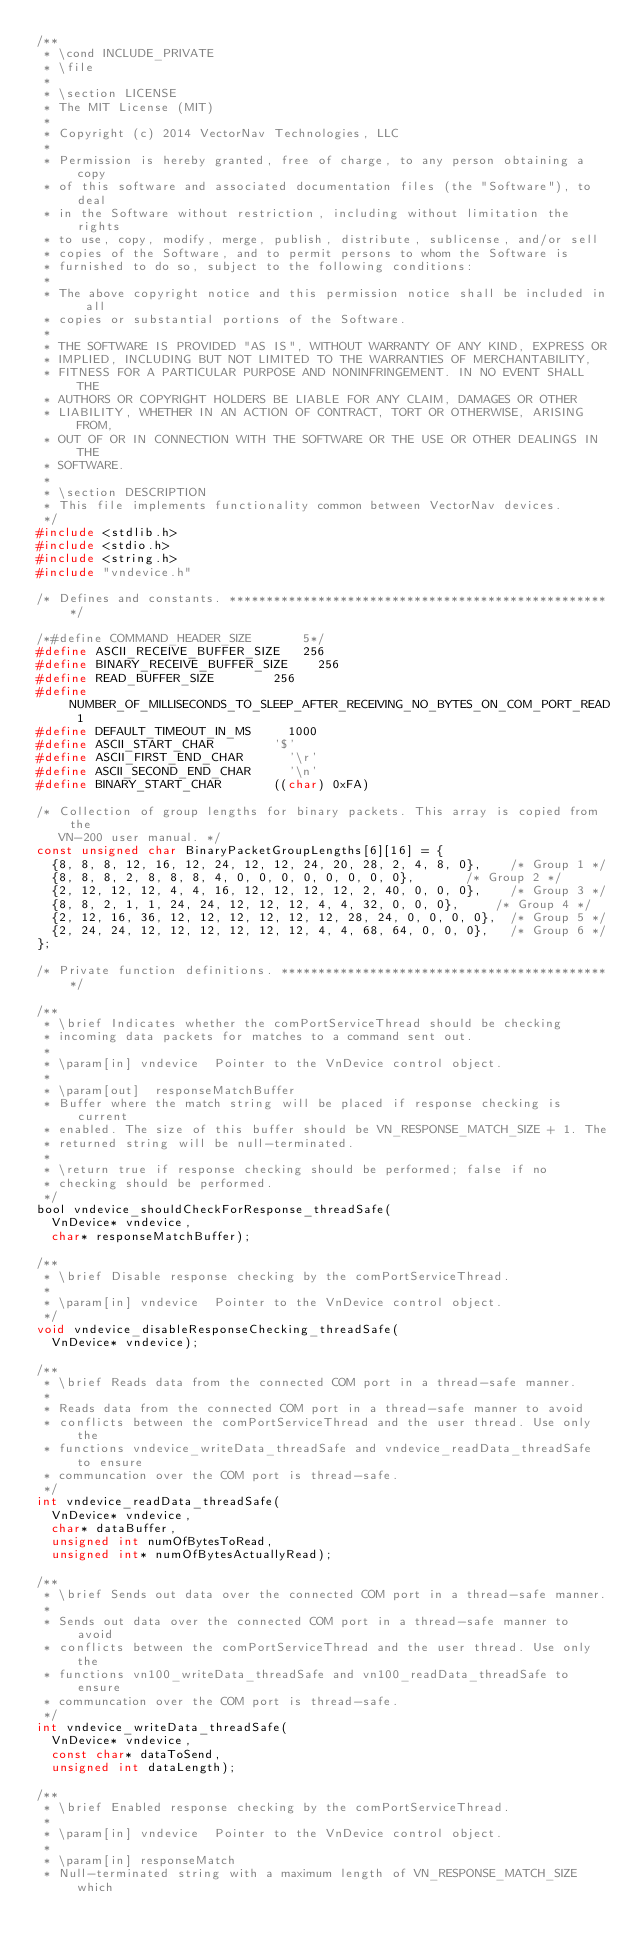<code> <loc_0><loc_0><loc_500><loc_500><_C_>/**
 * \cond INCLUDE_PRIVATE
 * \file
 *
 * \section LICENSE
 * The MIT License (MIT)
 *
 * Copyright (c) 2014 VectorNav Technologies, LLC
 *
 * Permission is hereby granted, free of charge, to any person obtaining a copy
 * of this software and associated documentation files (the "Software"), to deal
 * in the Software without restriction, including without limitation the rights
 * to use, copy, modify, merge, publish, distribute, sublicense, and/or sell
 * copies of the Software, and to permit persons to whom the Software is
 * furnished to do so, subject to the following conditions:
 *
 * The above copyright notice and this permission notice shall be included in all
 * copies or substantial portions of the Software.
 *
 * THE SOFTWARE IS PROVIDED "AS IS", WITHOUT WARRANTY OF ANY KIND, EXPRESS OR
 * IMPLIED, INCLUDING BUT NOT LIMITED TO THE WARRANTIES OF MERCHANTABILITY,
 * FITNESS FOR A PARTICULAR PURPOSE AND NONINFRINGEMENT. IN NO EVENT SHALL THE
 * AUTHORS OR COPYRIGHT HOLDERS BE LIABLE FOR ANY CLAIM, DAMAGES OR OTHER
 * LIABILITY, WHETHER IN AN ACTION OF CONTRACT, TORT OR OTHERWISE, ARISING FROM,
 * OUT OF OR IN CONNECTION WITH THE SOFTWARE OR THE USE OR OTHER DEALINGS IN THE
 * SOFTWARE.
 *
 * \section DESCRIPTION
 * This file implements functionality common between VectorNav devices.
 */
#include <stdlib.h>
#include <stdio.h>
#include <string.h>
#include "vndevice.h"

/* Defines and constants. ****************************************************/

/*#define COMMAND_HEADER_SIZE				5*/
#define ASCII_RECEIVE_BUFFER_SIZE		256
#define BINARY_RECEIVE_BUFFER_SIZE		256
#define READ_BUFFER_SIZE				256
#define NUMBER_OF_MILLISECONDS_TO_SLEEP_AFTER_RECEIVING_NO_BYTES_ON_COM_PORT_READ	1
#define DEFAULT_TIMEOUT_IN_MS			1000
#define ASCII_START_CHAR				'$'
#define ASCII_FIRST_END_CHAR			'\r'
#define ASCII_SECOND_END_CHAR			'\n'
#define BINARY_START_CHAR				((char) 0xFA)

/* Collection of group lengths for binary packets. This array is copied from the
   VN-200 user manual. */
const unsigned char BinaryPacketGroupLengths[6][16] = {
	{8, 8, 8, 12, 16, 12, 24, 12, 12, 24, 20, 28, 2, 4, 8, 0},		/* Group 1 */
	{8, 8, 8, 2, 8, 8, 8, 4, 0, 0, 0, 0, 0, 0, 0, 0},				/* Group 2 */
	{2, 12, 12, 12, 4, 4, 16, 12, 12, 12, 12, 2, 40, 0, 0, 0},		/* Group 3 */
	{8, 8, 2, 1, 1, 24, 24, 12, 12, 12, 4, 4, 32, 0, 0, 0},			/* Group 4 */
	{2, 12, 16, 36, 12, 12, 12, 12, 12, 12, 28, 24, 0, 0, 0, 0},	/* Group 5 */
	{2, 24, 24, 12, 12, 12, 12, 12, 12, 4, 4, 68, 64, 0, 0, 0},		/* Group 6 */
};

/* Private function definitions. *********************************************/

/**
 * \brief Indicates whether the comPortServiceThread should be checking
 * incoming data packets for matches to a command sent out.
 *
 * \param[in]	vndevice	Pointer to the VnDevice control object.
 *
 * \param[out]	responseMatchBuffer
 * Buffer where the match string will be placed if response checking is current
 * enabled. The size of this buffer should be VN_RESPONSE_MATCH_SIZE + 1. The
 * returned string will be null-terminated.
 *
 * \return true if response checking should be performed; false if no
 * checking should be performed.
 */
bool vndevice_shouldCheckForResponse_threadSafe(
	VnDevice* vndevice,
	char* responseMatchBuffer);

/**
 * \brief Disable response checking by the comPortServiceThread.
 *
 * \param[in]	vndevice	Pointer to the VnDevice control object.
 */
void vndevice_disableResponseChecking_threadSafe(
	VnDevice* vndevice);

/**
 * \brief Reads data from the connected COM port in a thread-safe manner.
 *
 * Reads data from the connected COM port in a thread-safe manner to avoid
 * conflicts between the comPortServiceThread and the user thread. Use only the
 * functions vndevice_writeData_threadSafe and vndevice_readData_threadSafe to ensure
 * communcation over the COM port is thread-safe.
 */
int vndevice_readData_threadSafe(
	VnDevice* vndevice,
	char* dataBuffer,
	unsigned int numOfBytesToRead,
	unsigned int* numOfBytesActuallyRead);

/**
 * \brief Sends out data over the connected COM port in a thread-safe manner.
 *
 * Sends out data over the connected COM port in a thread-safe manner to avoid
 * conflicts between the comPortServiceThread and the user thread. Use only the
 * functions vn100_writeData_threadSafe and vn100_readData_threadSafe to ensure
 * communcation over the COM port is thread-safe.
 */
int vndevice_writeData_threadSafe(
	VnDevice* vndevice,
	const char* dataToSend,
	unsigned int dataLength);

/**
 * \brief Enabled response checking by the comPortServiceThread.
 *
 * \param[in]	vndevice	Pointer to the VnDevice control object.
 *
 * \param[in]	responseMatch
 * Null-terminated string with a maximum length of VN_RESPONSE_MATCH_SIZE which</code> 